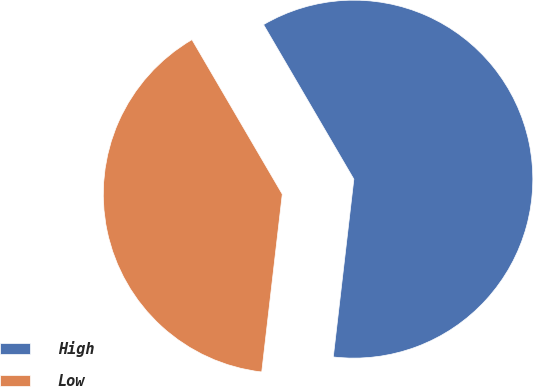<chart> <loc_0><loc_0><loc_500><loc_500><pie_chart><fcel>High<fcel>Low<nl><fcel>60.25%<fcel>39.75%<nl></chart> 